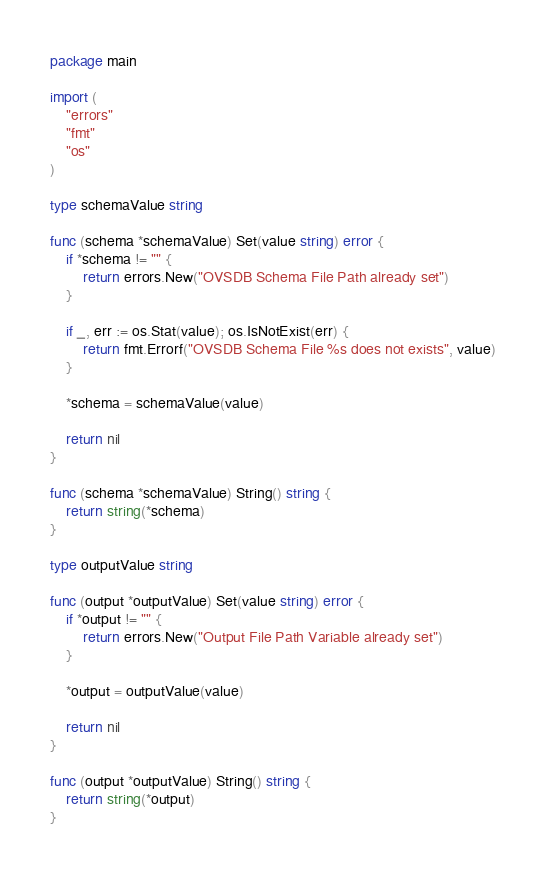Convert code to text. <code><loc_0><loc_0><loc_500><loc_500><_Go_>package main

import (
	"errors"
	"fmt"
	"os"
)

type schemaValue string

func (schema *schemaValue) Set(value string) error {
	if *schema != "" {
		return errors.New("OVSDB Schema File Path already set")
	}

	if _, err := os.Stat(value); os.IsNotExist(err) {
		return fmt.Errorf("OVSDB Schema File %s does not exists", value)
	}

	*schema = schemaValue(value)

	return nil
}

func (schema *schemaValue) String() string {
	return string(*schema)
}

type outputValue string

func (output *outputValue) Set(value string) error {
	if *output != "" {
		return errors.New("Output File Path Variable already set")
	}

	*output = outputValue(value)

	return nil
}

func (output *outputValue) String() string {
	return string(*output)
}
</code> 